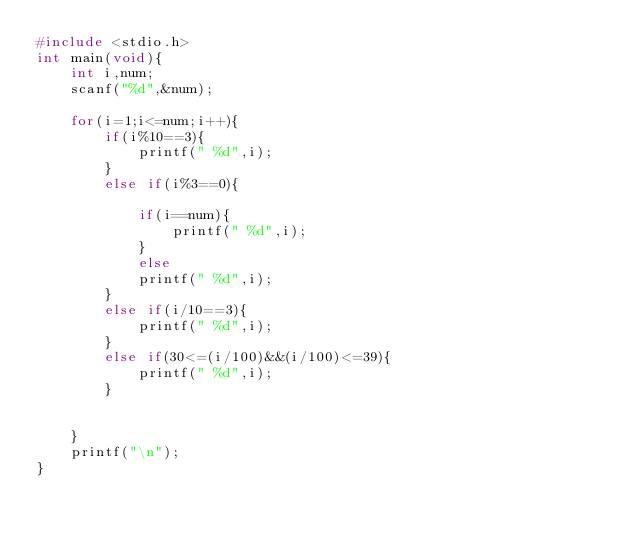Convert code to text. <code><loc_0><loc_0><loc_500><loc_500><_C_>#include <stdio.h>
int main(void){
    int i,num;
    scanf("%d",&num);
     
    for(i=1;i<=num;i++){
        if(i%10==3){
            printf(" %d",i);
        }
        else if(i%3==0){
             
            if(i==num){
                printf(" %d",i);
            }
            else
            printf(" %d",i);
        }
        else if(i/10==3){
            printf(" %d",i);
        }
        else if(30<=(i/100)&&(i/100)<=39){
            printf(" %d",i);
        }
        
        
    }
    printf("\n");
}
</code> 